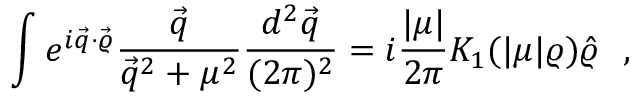<formula> <loc_0><loc_0><loc_500><loc_500>\int e ^ { i \vec { q } \cdot \vec { \varrho } } \frac { \vec { q } } { \vec { q } ^ { 2 } + \mu ^ { 2 } } \frac { d ^ { 2 } \vec { q } } { ( 2 \pi ) ^ { 2 } } = i \frac { | \mu | } { 2 \pi } K _ { 1 } ( | \mu | \varrho ) \hat { \varrho } ,</formula> 